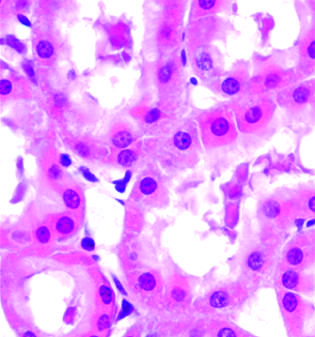what does ischemic injury show?
Answer the question using a single word or phrase. Surface blebs 